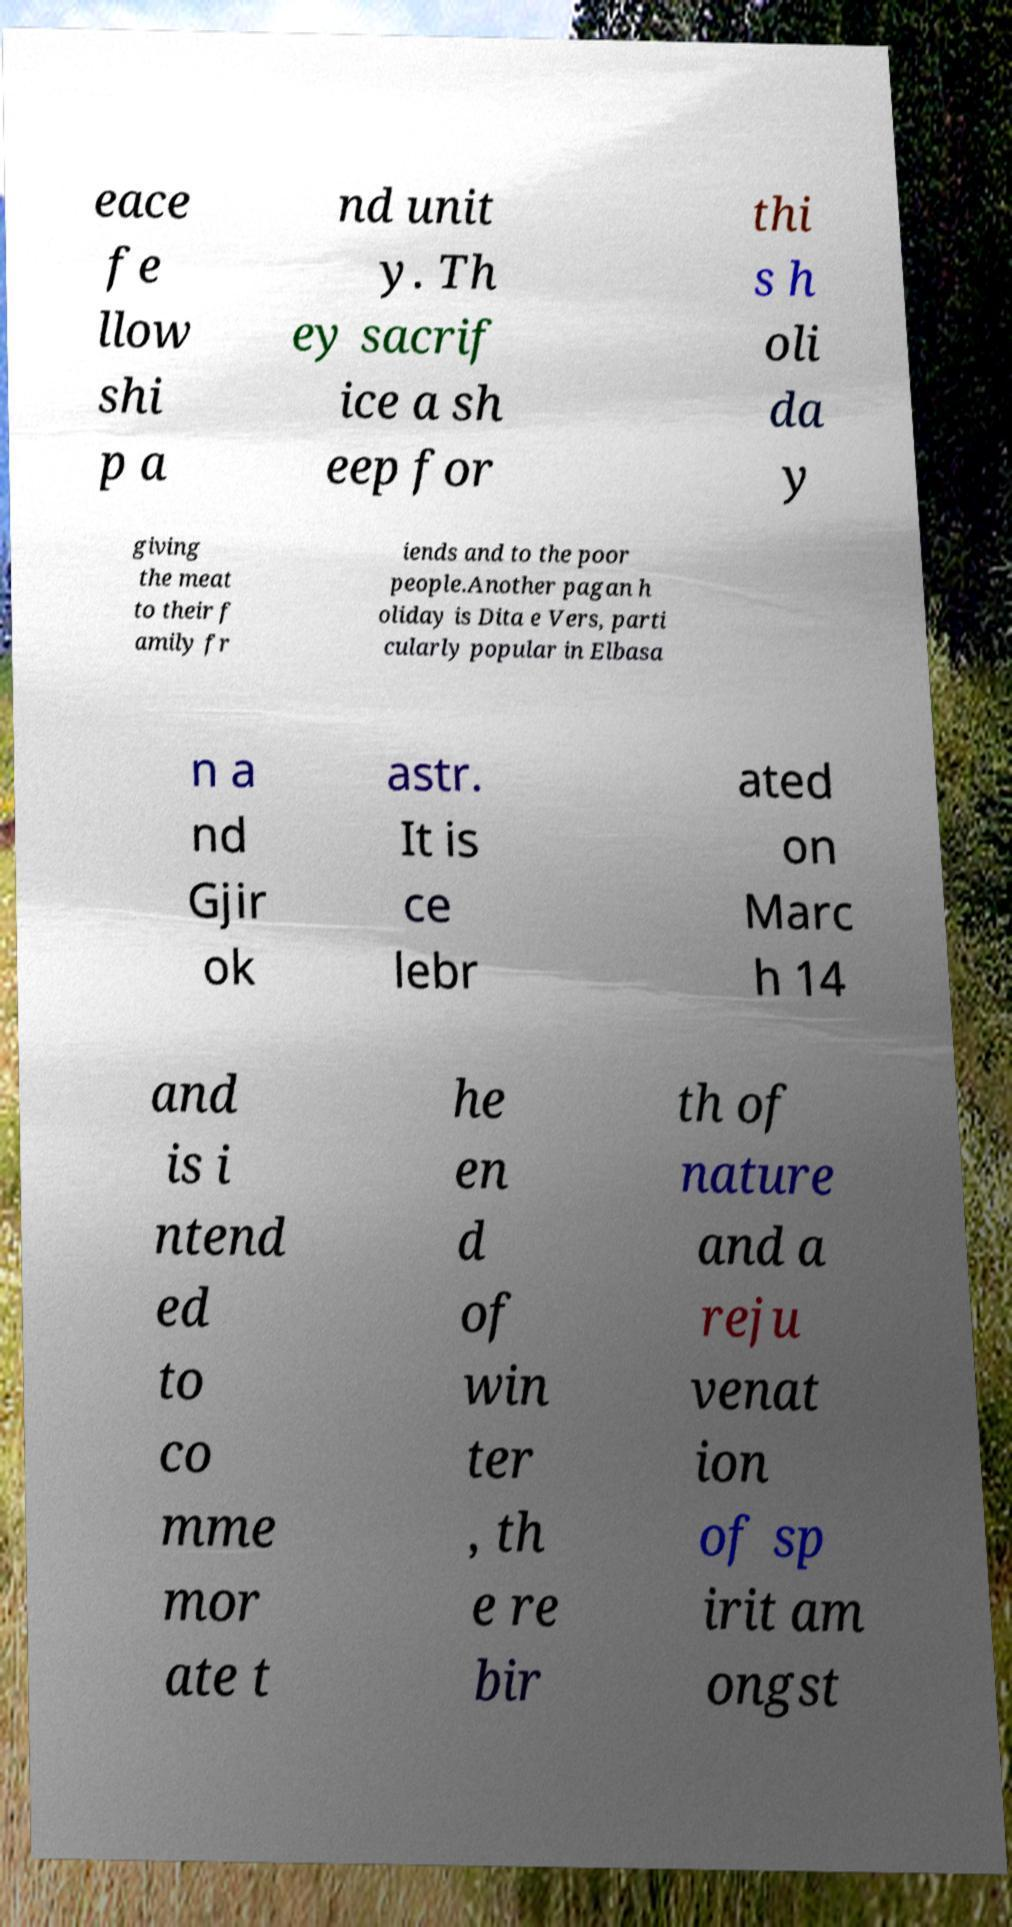Can you accurately transcribe the text from the provided image for me? eace fe llow shi p a nd unit y. Th ey sacrif ice a sh eep for thi s h oli da y giving the meat to their f amily fr iends and to the poor people.Another pagan h oliday is Dita e Vers, parti cularly popular in Elbasa n a nd Gjir ok astr. It is ce lebr ated on Marc h 14 and is i ntend ed to co mme mor ate t he en d of win ter , th e re bir th of nature and a reju venat ion of sp irit am ongst 